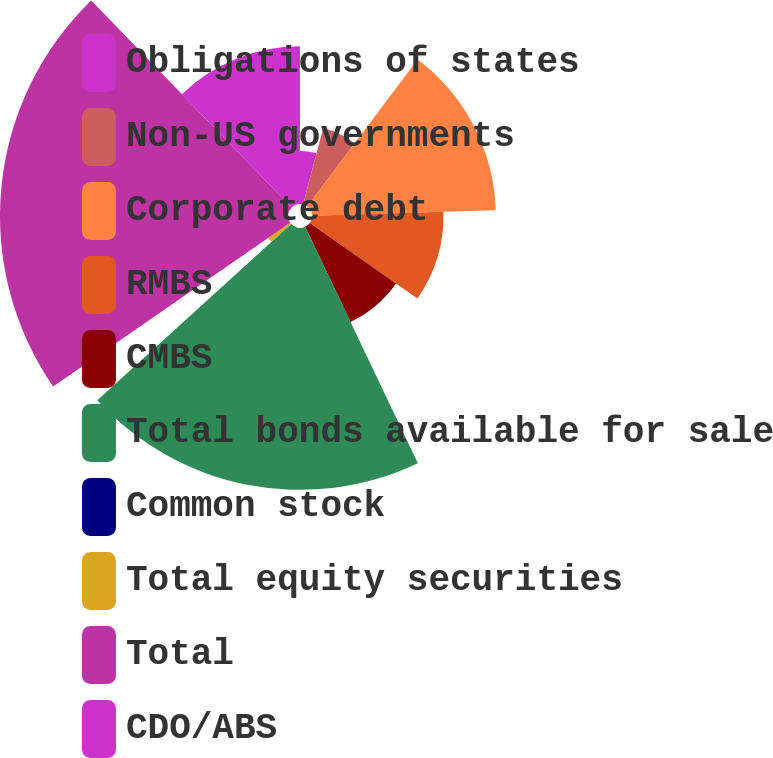Convert chart to OTSL. <chart><loc_0><loc_0><loc_500><loc_500><pie_chart><fcel>Obligations of states<fcel>Non-US governments<fcel>Corporate debt<fcel>RMBS<fcel>CMBS<fcel>Total bonds available for sale<fcel>Common stock<fcel>Total equity securities<fcel>Total<fcel>CDO/ABS<nl><fcel>4.11%<fcel>6.14%<fcel>14.28%<fcel>10.21%<fcel>8.18%<fcel>20.34%<fcel>0.04%<fcel>2.08%<fcel>22.37%<fcel>12.25%<nl></chart> 